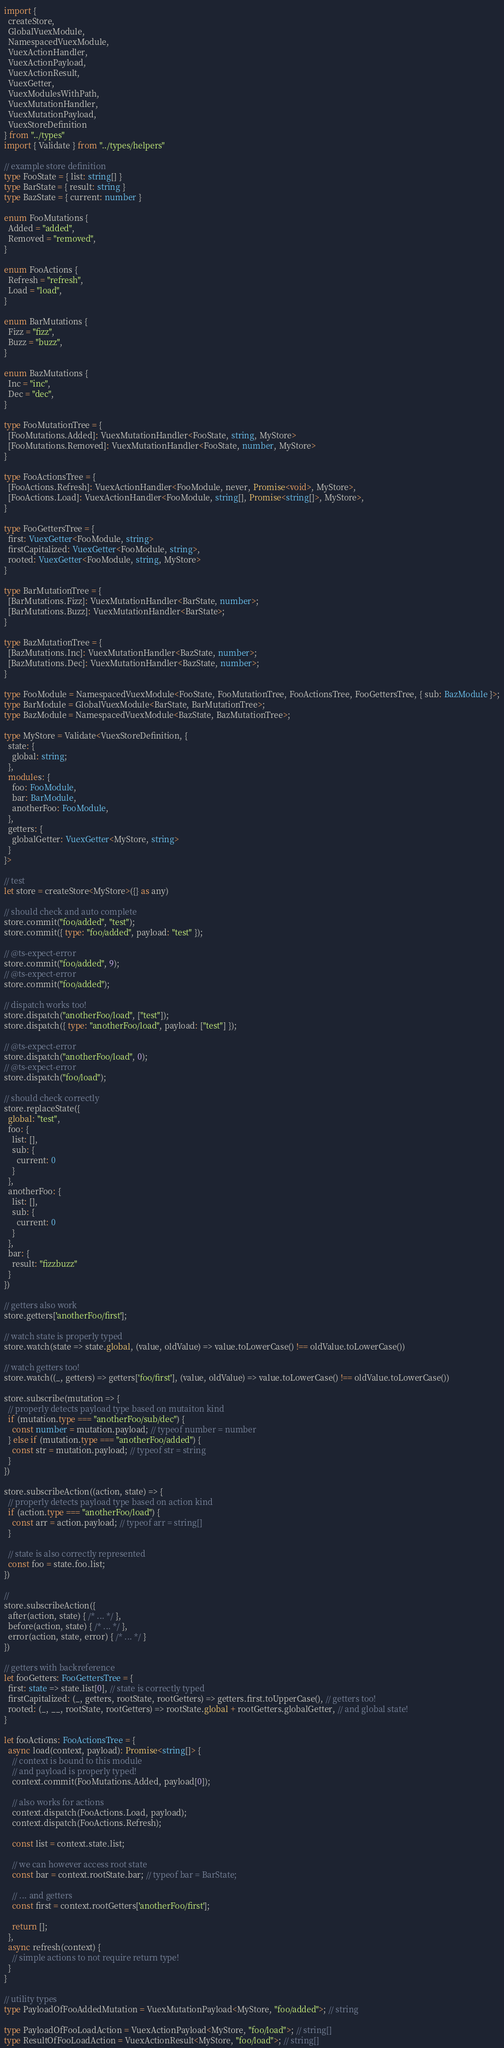Convert code to text. <code><loc_0><loc_0><loc_500><loc_500><_TypeScript_>import {
  createStore,
  GlobalVuexModule,
  NamespacedVuexModule,
  VuexActionHandler,
  VuexActionPayload,
  VuexActionResult,
  VuexGetter,
  VuexModulesWithPath,
  VuexMutationHandler,
  VuexMutationPayload,
  VuexStoreDefinition
} from "../types"
import { Validate } from "../types/helpers"

// example store definition
type FooState = { list: string[] }
type BarState = { result: string }
type BazState = { current: number }

enum FooMutations {
  Added = "added",
  Removed = "removed",
}

enum FooActions {
  Refresh = "refresh",
  Load = "load",
}

enum BarMutations {
  Fizz = "fizz",
  Buzz = "buzz",
}

enum BazMutations {
  Inc = "inc",
  Dec = "dec",
}

type FooMutationTree = {
  [FooMutations.Added]: VuexMutationHandler<FooState, string, MyStore>
  [FooMutations.Removed]: VuexMutationHandler<FooState, number, MyStore>
}

type FooActionsTree = {
  [FooActions.Refresh]: VuexActionHandler<FooModule, never, Promise<void>, MyStore>,
  [FooActions.Load]: VuexActionHandler<FooModule, string[], Promise<string[]>, MyStore>,
}

type FooGettersTree = {
  first: VuexGetter<FooModule, string>
  firstCapitalized: VuexGetter<FooModule, string>,
  rooted: VuexGetter<FooModule, string, MyStore>
}

type BarMutationTree = {
  [BarMutations.Fizz]: VuexMutationHandler<BarState, number>;
  [BarMutations.Buzz]: VuexMutationHandler<BarState>;
}

type BazMutationTree = {
  [BazMutations.Inc]: VuexMutationHandler<BazState, number>;
  [BazMutations.Dec]: VuexMutationHandler<BazState, number>;
}

type FooModule = NamespacedVuexModule<FooState, FooMutationTree, FooActionsTree, FooGettersTree, { sub: BazModule }>;
type BarModule = GlobalVuexModule<BarState, BarMutationTree>;
type BazModule = NamespacedVuexModule<BazState, BazMutationTree>;

type MyStore = Validate<VuexStoreDefinition, {
  state: {
    global: string;
  },
  modules: {
    foo: FooModule,
    bar: BarModule,
    anotherFoo: FooModule,
  },
  getters: {
    globalGetter: VuexGetter<MyStore, string>
  }
}>

// test
let store = createStore<MyStore>({} as any)

// should check and auto complete
store.commit("foo/added", "test");
store.commit({ type: "foo/added", payload: "test" });

// @ts-expect-error
store.commit("foo/added", 9);
// @ts-expect-error
store.commit("foo/added");

// dispatch works too!
store.dispatch("anotherFoo/load", ["test"]);
store.dispatch({ type: "anotherFoo/load", payload: ["test"] });

// @ts-expect-error
store.dispatch("anotherFoo/load", 0);
// @ts-expect-error
store.dispatch("foo/load");

// should check correctly
store.replaceState({
  global: "test",
  foo: {
    list: [],
    sub: {
      current: 0
    }
  },
  anotherFoo: {
    list: [],
    sub: {
      current: 0
    }
  },
  bar: {
    result: "fizzbuzz"
  }
})

// getters also work
store.getters['anotherFoo/first'];

// watch state is properly typed
store.watch(state => state.global, (value, oldValue) => value.toLowerCase() !== oldValue.toLowerCase())

// watch getters too!
store.watch((_, getters) => getters['foo/first'], (value, oldValue) => value.toLowerCase() !== oldValue.toLowerCase())

store.subscribe(mutation => {
  // properly detects payload type based on mutaiton kind
  if (mutation.type === "anotherFoo/sub/dec") {
    const number = mutation.payload; // typeof number = number
  } else if (mutation.type === "anotherFoo/added") {
    const str = mutation.payload; // typeof str = string
  }
})

store.subscribeAction((action, state) => {
  // properly detects payload type based on action kind
  if (action.type === "anotherFoo/load") {
    const arr = action.payload; // typeof arr = string[]
  }

  // state is also correctly represented
  const foo = state.foo.list;
})

// 
store.subscribeAction({
  after(action, state) { /* ... */ },
  before(action, state) { /* ... */ },
  error(action, state, error) { /* ... */ }
})

// getters with backreference
let fooGetters: FooGettersTree = {
  first: state => state.list[0], // state is correctly typed
  firstCapitalized: (_, getters, rootState, rootGetters) => getters.first.toUpperCase(), // getters too!
  rooted: (_, __, rootState, rootGetters) => rootState.global + rootGetters.globalGetter, // and global state!
}

let fooActions: FooActionsTree = {
  async load(context, payload): Promise<string[]> {
    // context is bound to this module
    // and payload is properly typed!
    context.commit(FooMutations.Added, payload[0]);

    // also works for actions
    context.dispatch(FooActions.Load, payload);
    context.dispatch(FooActions.Refresh);

    const list = context.state.list;

    // we can however access root state
    const bar = context.rootState.bar; // typeof bar = BarState;

    // ... and getters
    const first = context.rootGetters['anotherFoo/first'];

    return [];
  },
  async refresh(context) {
    // simple actions to not require return type!
  }
}

// utility types
type PayloadOfFooAddedMutation = VuexMutationPayload<MyStore, "foo/added">; // string

type PayloadOfFooLoadAction = VuexActionPayload<MyStore, "foo/load">; // string[]
type ResultOfFooLoadAction = VuexActionResult<MyStore, "foo/load">; // string[]
</code> 